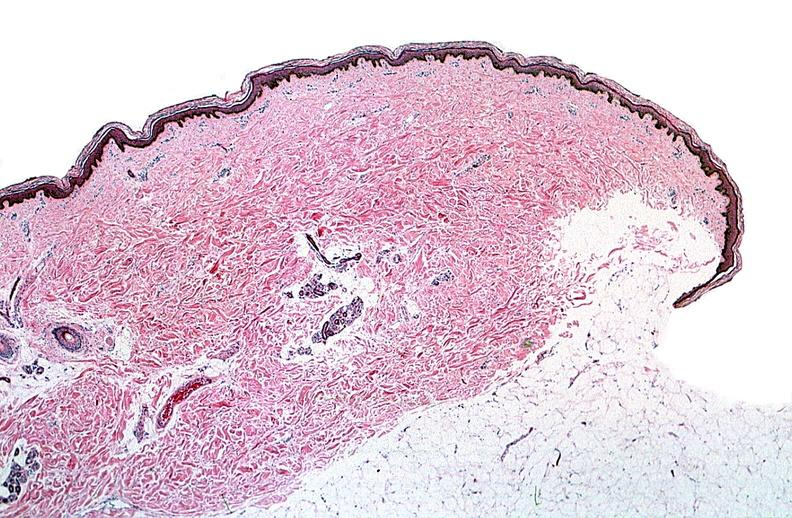does maxillary sinus show thermal burned skin?
Answer the question using a single word or phrase. No 